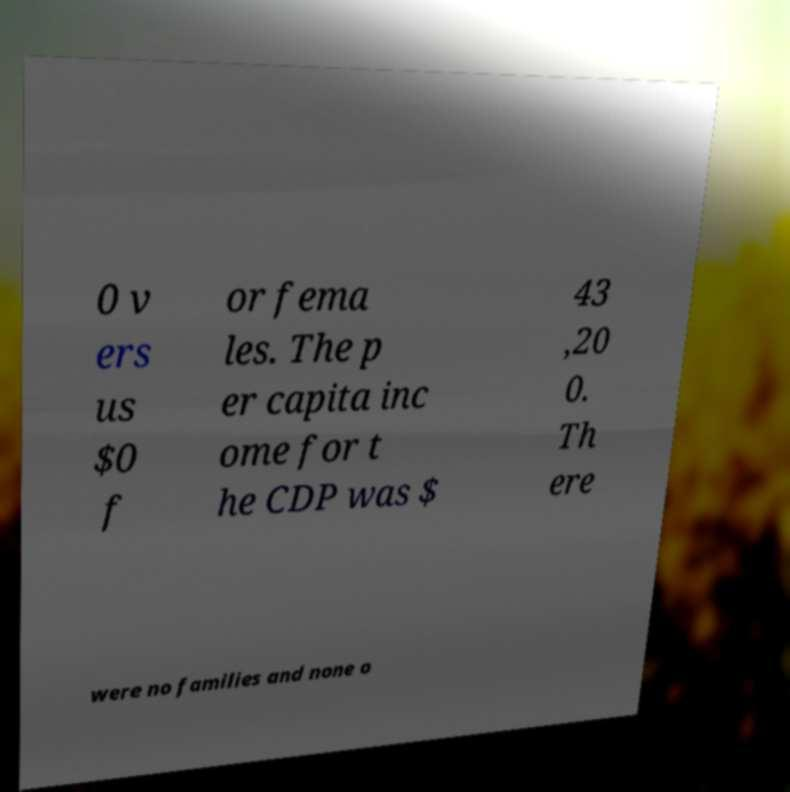Can you read and provide the text displayed in the image?This photo seems to have some interesting text. Can you extract and type it out for me? 0 v ers us $0 f or fema les. The p er capita inc ome for t he CDP was $ 43 ,20 0. Th ere were no families and none o 